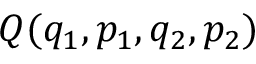<formula> <loc_0><loc_0><loc_500><loc_500>Q ( q _ { 1 } , p _ { 1 } , q _ { 2 } , p _ { 2 } )</formula> 